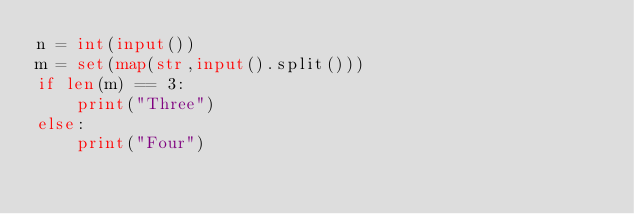Convert code to text. <code><loc_0><loc_0><loc_500><loc_500><_Python_>n = int(input())
m = set(map(str,input().split()))
if len(m) == 3:
    print("Three")
else:
    print("Four")</code> 